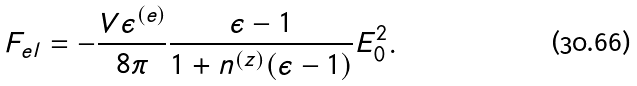<formula> <loc_0><loc_0><loc_500><loc_500>F _ { e l } = - \frac { V \epsilon ^ { ( e ) } } { 8 \pi } \frac { \epsilon - 1 } { 1 + n ^ { ( z ) } ( \epsilon - 1 ) } E _ { 0 } ^ { 2 } .</formula> 